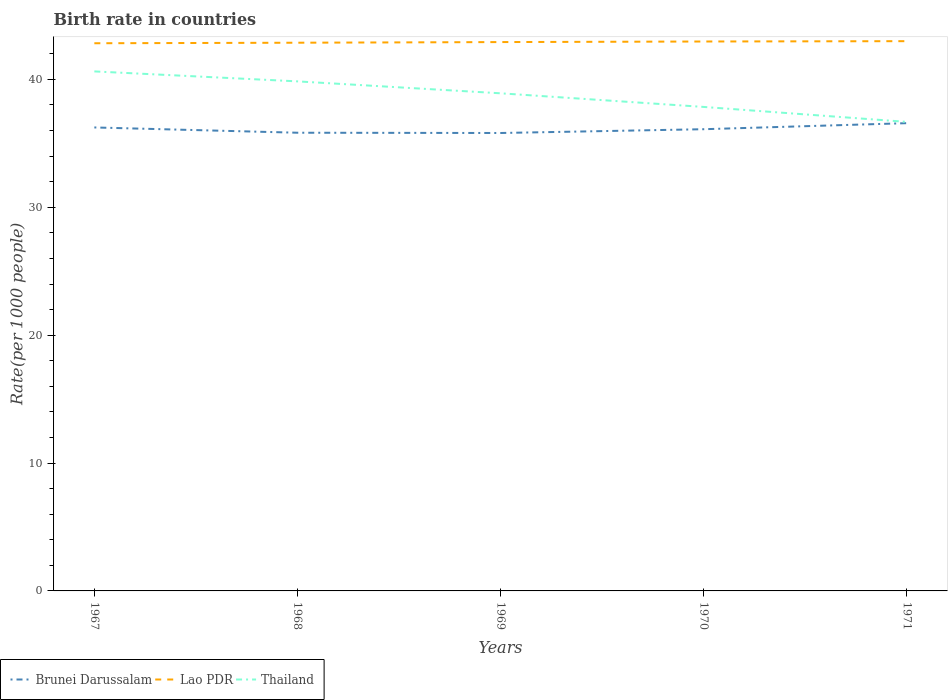Across all years, what is the maximum birth rate in Lao PDR?
Your response must be concise. 42.83. What is the total birth rate in Lao PDR in the graph?
Provide a short and direct response. -0.09. What is the difference between the highest and the second highest birth rate in Lao PDR?
Provide a short and direct response. 0.16. What is the difference between the highest and the lowest birth rate in Thailand?
Your answer should be compact. 3. Is the birth rate in Brunei Darussalam strictly greater than the birth rate in Lao PDR over the years?
Your answer should be very brief. Yes. How many lines are there?
Give a very brief answer. 3. How many years are there in the graph?
Keep it short and to the point. 5. Are the values on the major ticks of Y-axis written in scientific E-notation?
Keep it short and to the point. No. Does the graph contain any zero values?
Offer a terse response. No. Does the graph contain grids?
Give a very brief answer. No. How are the legend labels stacked?
Provide a short and direct response. Horizontal. What is the title of the graph?
Offer a very short reply. Birth rate in countries. Does "Korea (Republic)" appear as one of the legend labels in the graph?
Offer a very short reply. No. What is the label or title of the X-axis?
Provide a short and direct response. Years. What is the label or title of the Y-axis?
Your response must be concise. Rate(per 1000 people). What is the Rate(per 1000 people) of Brunei Darussalam in 1967?
Offer a very short reply. 36.24. What is the Rate(per 1000 people) in Lao PDR in 1967?
Offer a terse response. 42.83. What is the Rate(per 1000 people) in Thailand in 1967?
Offer a very short reply. 40.62. What is the Rate(per 1000 people) in Brunei Darussalam in 1968?
Offer a very short reply. 35.83. What is the Rate(per 1000 people) in Lao PDR in 1968?
Offer a terse response. 42.87. What is the Rate(per 1000 people) in Thailand in 1968?
Keep it short and to the point. 39.85. What is the Rate(per 1000 people) in Brunei Darussalam in 1969?
Provide a short and direct response. 35.81. What is the Rate(per 1000 people) of Lao PDR in 1969?
Your answer should be very brief. 42.92. What is the Rate(per 1000 people) of Thailand in 1969?
Provide a succinct answer. 38.91. What is the Rate(per 1000 people) of Brunei Darussalam in 1970?
Your response must be concise. 36.1. What is the Rate(per 1000 people) in Lao PDR in 1970?
Your answer should be compact. 42.96. What is the Rate(per 1000 people) of Thailand in 1970?
Your answer should be compact. 37.85. What is the Rate(per 1000 people) of Brunei Darussalam in 1971?
Ensure brevity in your answer.  36.58. What is the Rate(per 1000 people) in Lao PDR in 1971?
Offer a very short reply. 42.99. What is the Rate(per 1000 people) in Thailand in 1971?
Make the answer very short. 36.68. Across all years, what is the maximum Rate(per 1000 people) of Brunei Darussalam?
Keep it short and to the point. 36.58. Across all years, what is the maximum Rate(per 1000 people) in Lao PDR?
Ensure brevity in your answer.  42.99. Across all years, what is the maximum Rate(per 1000 people) of Thailand?
Keep it short and to the point. 40.62. Across all years, what is the minimum Rate(per 1000 people) in Brunei Darussalam?
Your response must be concise. 35.81. Across all years, what is the minimum Rate(per 1000 people) in Lao PDR?
Your answer should be compact. 42.83. Across all years, what is the minimum Rate(per 1000 people) of Thailand?
Your answer should be very brief. 36.68. What is the total Rate(per 1000 people) in Brunei Darussalam in the graph?
Your response must be concise. 180.56. What is the total Rate(per 1000 people) in Lao PDR in the graph?
Your answer should be very brief. 214.57. What is the total Rate(per 1000 people) of Thailand in the graph?
Your answer should be compact. 193.91. What is the difference between the Rate(per 1000 people) in Brunei Darussalam in 1967 and that in 1968?
Offer a very short reply. 0.41. What is the difference between the Rate(per 1000 people) in Lao PDR in 1967 and that in 1968?
Keep it short and to the point. -0.04. What is the difference between the Rate(per 1000 people) of Thailand in 1967 and that in 1968?
Your answer should be very brief. 0.78. What is the difference between the Rate(per 1000 people) of Brunei Darussalam in 1967 and that in 1969?
Provide a short and direct response. 0.43. What is the difference between the Rate(per 1000 people) in Lao PDR in 1967 and that in 1969?
Your answer should be very brief. -0.09. What is the difference between the Rate(per 1000 people) of Thailand in 1967 and that in 1969?
Give a very brief answer. 1.71. What is the difference between the Rate(per 1000 people) in Brunei Darussalam in 1967 and that in 1970?
Provide a succinct answer. 0.14. What is the difference between the Rate(per 1000 people) of Lao PDR in 1967 and that in 1970?
Your answer should be very brief. -0.14. What is the difference between the Rate(per 1000 people) in Thailand in 1967 and that in 1970?
Your response must be concise. 2.78. What is the difference between the Rate(per 1000 people) of Brunei Darussalam in 1967 and that in 1971?
Your response must be concise. -0.34. What is the difference between the Rate(per 1000 people) of Lao PDR in 1967 and that in 1971?
Your answer should be very brief. -0.16. What is the difference between the Rate(per 1000 people) in Thailand in 1967 and that in 1971?
Provide a short and direct response. 3.95. What is the difference between the Rate(per 1000 people) in Brunei Darussalam in 1968 and that in 1969?
Make the answer very short. 0.02. What is the difference between the Rate(per 1000 people) in Lao PDR in 1968 and that in 1969?
Make the answer very short. -0.05. What is the difference between the Rate(per 1000 people) in Thailand in 1968 and that in 1969?
Provide a short and direct response. 0.93. What is the difference between the Rate(per 1000 people) in Brunei Darussalam in 1968 and that in 1970?
Ensure brevity in your answer.  -0.28. What is the difference between the Rate(per 1000 people) in Lao PDR in 1968 and that in 1970?
Your response must be concise. -0.1. What is the difference between the Rate(per 1000 people) in Thailand in 1968 and that in 1970?
Offer a terse response. 2. What is the difference between the Rate(per 1000 people) of Brunei Darussalam in 1968 and that in 1971?
Ensure brevity in your answer.  -0.75. What is the difference between the Rate(per 1000 people) in Lao PDR in 1968 and that in 1971?
Provide a succinct answer. -0.12. What is the difference between the Rate(per 1000 people) in Thailand in 1968 and that in 1971?
Provide a succinct answer. 3.17. What is the difference between the Rate(per 1000 people) in Brunei Darussalam in 1969 and that in 1970?
Keep it short and to the point. -0.3. What is the difference between the Rate(per 1000 people) of Lao PDR in 1969 and that in 1970?
Offer a very short reply. -0.04. What is the difference between the Rate(per 1000 people) in Thailand in 1969 and that in 1970?
Provide a short and direct response. 1.07. What is the difference between the Rate(per 1000 people) in Brunei Darussalam in 1969 and that in 1971?
Your response must be concise. -0.77. What is the difference between the Rate(per 1000 people) in Lao PDR in 1969 and that in 1971?
Ensure brevity in your answer.  -0.07. What is the difference between the Rate(per 1000 people) in Thailand in 1969 and that in 1971?
Offer a terse response. 2.24. What is the difference between the Rate(per 1000 people) in Brunei Darussalam in 1970 and that in 1971?
Your response must be concise. -0.47. What is the difference between the Rate(per 1000 people) in Lao PDR in 1970 and that in 1971?
Your answer should be very brief. -0.03. What is the difference between the Rate(per 1000 people) in Thailand in 1970 and that in 1971?
Your response must be concise. 1.17. What is the difference between the Rate(per 1000 people) of Brunei Darussalam in 1967 and the Rate(per 1000 people) of Lao PDR in 1968?
Your response must be concise. -6.63. What is the difference between the Rate(per 1000 people) of Brunei Darussalam in 1967 and the Rate(per 1000 people) of Thailand in 1968?
Your response must be concise. -3.6. What is the difference between the Rate(per 1000 people) of Lao PDR in 1967 and the Rate(per 1000 people) of Thailand in 1968?
Make the answer very short. 2.98. What is the difference between the Rate(per 1000 people) in Brunei Darussalam in 1967 and the Rate(per 1000 people) in Lao PDR in 1969?
Provide a short and direct response. -6.68. What is the difference between the Rate(per 1000 people) of Brunei Darussalam in 1967 and the Rate(per 1000 people) of Thailand in 1969?
Your response must be concise. -2.67. What is the difference between the Rate(per 1000 people) of Lao PDR in 1967 and the Rate(per 1000 people) of Thailand in 1969?
Ensure brevity in your answer.  3.91. What is the difference between the Rate(per 1000 people) in Brunei Darussalam in 1967 and the Rate(per 1000 people) in Lao PDR in 1970?
Your answer should be compact. -6.72. What is the difference between the Rate(per 1000 people) of Brunei Darussalam in 1967 and the Rate(per 1000 people) of Thailand in 1970?
Provide a succinct answer. -1.6. What is the difference between the Rate(per 1000 people) of Lao PDR in 1967 and the Rate(per 1000 people) of Thailand in 1970?
Give a very brief answer. 4.98. What is the difference between the Rate(per 1000 people) of Brunei Darussalam in 1967 and the Rate(per 1000 people) of Lao PDR in 1971?
Your answer should be very brief. -6.75. What is the difference between the Rate(per 1000 people) in Brunei Darussalam in 1967 and the Rate(per 1000 people) in Thailand in 1971?
Provide a succinct answer. -0.43. What is the difference between the Rate(per 1000 people) in Lao PDR in 1967 and the Rate(per 1000 people) in Thailand in 1971?
Your answer should be compact. 6.15. What is the difference between the Rate(per 1000 people) in Brunei Darussalam in 1968 and the Rate(per 1000 people) in Lao PDR in 1969?
Provide a short and direct response. -7.09. What is the difference between the Rate(per 1000 people) in Brunei Darussalam in 1968 and the Rate(per 1000 people) in Thailand in 1969?
Your answer should be very brief. -3.08. What is the difference between the Rate(per 1000 people) in Lao PDR in 1968 and the Rate(per 1000 people) in Thailand in 1969?
Make the answer very short. 3.96. What is the difference between the Rate(per 1000 people) of Brunei Darussalam in 1968 and the Rate(per 1000 people) of Lao PDR in 1970?
Offer a very short reply. -7.13. What is the difference between the Rate(per 1000 people) in Brunei Darussalam in 1968 and the Rate(per 1000 people) in Thailand in 1970?
Your answer should be very brief. -2.02. What is the difference between the Rate(per 1000 people) in Lao PDR in 1968 and the Rate(per 1000 people) in Thailand in 1970?
Ensure brevity in your answer.  5.02. What is the difference between the Rate(per 1000 people) of Brunei Darussalam in 1968 and the Rate(per 1000 people) of Lao PDR in 1971?
Provide a succinct answer. -7.16. What is the difference between the Rate(per 1000 people) in Brunei Darussalam in 1968 and the Rate(per 1000 people) in Thailand in 1971?
Your answer should be very brief. -0.85. What is the difference between the Rate(per 1000 people) in Lao PDR in 1968 and the Rate(per 1000 people) in Thailand in 1971?
Provide a short and direct response. 6.19. What is the difference between the Rate(per 1000 people) in Brunei Darussalam in 1969 and the Rate(per 1000 people) in Lao PDR in 1970?
Make the answer very short. -7.16. What is the difference between the Rate(per 1000 people) of Brunei Darussalam in 1969 and the Rate(per 1000 people) of Thailand in 1970?
Provide a succinct answer. -2.04. What is the difference between the Rate(per 1000 people) in Lao PDR in 1969 and the Rate(per 1000 people) in Thailand in 1970?
Give a very brief answer. 5.07. What is the difference between the Rate(per 1000 people) of Brunei Darussalam in 1969 and the Rate(per 1000 people) of Lao PDR in 1971?
Ensure brevity in your answer.  -7.18. What is the difference between the Rate(per 1000 people) in Brunei Darussalam in 1969 and the Rate(per 1000 people) in Thailand in 1971?
Ensure brevity in your answer.  -0.87. What is the difference between the Rate(per 1000 people) of Lao PDR in 1969 and the Rate(per 1000 people) of Thailand in 1971?
Ensure brevity in your answer.  6.24. What is the difference between the Rate(per 1000 people) of Brunei Darussalam in 1970 and the Rate(per 1000 people) of Lao PDR in 1971?
Your answer should be compact. -6.88. What is the difference between the Rate(per 1000 people) of Brunei Darussalam in 1970 and the Rate(per 1000 people) of Thailand in 1971?
Your answer should be very brief. -0.57. What is the difference between the Rate(per 1000 people) in Lao PDR in 1970 and the Rate(per 1000 people) in Thailand in 1971?
Provide a short and direct response. 6.29. What is the average Rate(per 1000 people) in Brunei Darussalam per year?
Offer a very short reply. 36.11. What is the average Rate(per 1000 people) of Lao PDR per year?
Offer a terse response. 42.91. What is the average Rate(per 1000 people) of Thailand per year?
Provide a short and direct response. 38.78. In the year 1967, what is the difference between the Rate(per 1000 people) in Brunei Darussalam and Rate(per 1000 people) in Lao PDR?
Ensure brevity in your answer.  -6.58. In the year 1967, what is the difference between the Rate(per 1000 people) of Brunei Darussalam and Rate(per 1000 people) of Thailand?
Provide a short and direct response. -4.38. In the year 1967, what is the difference between the Rate(per 1000 people) of Lao PDR and Rate(per 1000 people) of Thailand?
Keep it short and to the point. 2.2. In the year 1968, what is the difference between the Rate(per 1000 people) of Brunei Darussalam and Rate(per 1000 people) of Lao PDR?
Your answer should be very brief. -7.04. In the year 1968, what is the difference between the Rate(per 1000 people) in Brunei Darussalam and Rate(per 1000 people) in Thailand?
Provide a short and direct response. -4.02. In the year 1968, what is the difference between the Rate(per 1000 people) of Lao PDR and Rate(per 1000 people) of Thailand?
Your response must be concise. 3.02. In the year 1969, what is the difference between the Rate(per 1000 people) of Brunei Darussalam and Rate(per 1000 people) of Lao PDR?
Give a very brief answer. -7.11. In the year 1969, what is the difference between the Rate(per 1000 people) in Brunei Darussalam and Rate(per 1000 people) in Thailand?
Make the answer very short. -3.1. In the year 1969, what is the difference between the Rate(per 1000 people) in Lao PDR and Rate(per 1000 people) in Thailand?
Give a very brief answer. 4.01. In the year 1970, what is the difference between the Rate(per 1000 people) of Brunei Darussalam and Rate(per 1000 people) of Lao PDR?
Provide a short and direct response. -6.86. In the year 1970, what is the difference between the Rate(per 1000 people) in Brunei Darussalam and Rate(per 1000 people) in Thailand?
Offer a terse response. -1.74. In the year 1970, what is the difference between the Rate(per 1000 people) of Lao PDR and Rate(per 1000 people) of Thailand?
Make the answer very short. 5.12. In the year 1971, what is the difference between the Rate(per 1000 people) of Brunei Darussalam and Rate(per 1000 people) of Lao PDR?
Ensure brevity in your answer.  -6.41. In the year 1971, what is the difference between the Rate(per 1000 people) of Brunei Darussalam and Rate(per 1000 people) of Thailand?
Your answer should be very brief. -0.1. In the year 1971, what is the difference between the Rate(per 1000 people) of Lao PDR and Rate(per 1000 people) of Thailand?
Keep it short and to the point. 6.31. What is the ratio of the Rate(per 1000 people) of Brunei Darussalam in 1967 to that in 1968?
Provide a short and direct response. 1.01. What is the ratio of the Rate(per 1000 people) in Lao PDR in 1967 to that in 1968?
Make the answer very short. 1. What is the ratio of the Rate(per 1000 people) in Thailand in 1967 to that in 1968?
Make the answer very short. 1.02. What is the ratio of the Rate(per 1000 people) in Brunei Darussalam in 1967 to that in 1969?
Keep it short and to the point. 1.01. What is the ratio of the Rate(per 1000 people) of Lao PDR in 1967 to that in 1969?
Ensure brevity in your answer.  1. What is the ratio of the Rate(per 1000 people) of Thailand in 1967 to that in 1969?
Offer a very short reply. 1.04. What is the ratio of the Rate(per 1000 people) of Brunei Darussalam in 1967 to that in 1970?
Make the answer very short. 1. What is the ratio of the Rate(per 1000 people) of Lao PDR in 1967 to that in 1970?
Offer a very short reply. 1. What is the ratio of the Rate(per 1000 people) in Thailand in 1967 to that in 1970?
Give a very brief answer. 1.07. What is the ratio of the Rate(per 1000 people) of Thailand in 1967 to that in 1971?
Your answer should be very brief. 1.11. What is the ratio of the Rate(per 1000 people) of Brunei Darussalam in 1968 to that in 1969?
Your response must be concise. 1. What is the ratio of the Rate(per 1000 people) in Lao PDR in 1968 to that in 1969?
Offer a very short reply. 1. What is the ratio of the Rate(per 1000 people) of Lao PDR in 1968 to that in 1970?
Your response must be concise. 1. What is the ratio of the Rate(per 1000 people) in Thailand in 1968 to that in 1970?
Offer a very short reply. 1.05. What is the ratio of the Rate(per 1000 people) of Brunei Darussalam in 1968 to that in 1971?
Your response must be concise. 0.98. What is the ratio of the Rate(per 1000 people) in Thailand in 1968 to that in 1971?
Your answer should be compact. 1.09. What is the ratio of the Rate(per 1000 people) of Brunei Darussalam in 1969 to that in 1970?
Ensure brevity in your answer.  0.99. What is the ratio of the Rate(per 1000 people) in Thailand in 1969 to that in 1970?
Offer a very short reply. 1.03. What is the ratio of the Rate(per 1000 people) of Lao PDR in 1969 to that in 1971?
Offer a terse response. 1. What is the ratio of the Rate(per 1000 people) of Thailand in 1969 to that in 1971?
Your answer should be very brief. 1.06. What is the ratio of the Rate(per 1000 people) in Brunei Darussalam in 1970 to that in 1971?
Your response must be concise. 0.99. What is the ratio of the Rate(per 1000 people) in Lao PDR in 1970 to that in 1971?
Your response must be concise. 1. What is the ratio of the Rate(per 1000 people) of Thailand in 1970 to that in 1971?
Keep it short and to the point. 1.03. What is the difference between the highest and the second highest Rate(per 1000 people) in Brunei Darussalam?
Ensure brevity in your answer.  0.34. What is the difference between the highest and the second highest Rate(per 1000 people) of Lao PDR?
Give a very brief answer. 0.03. What is the difference between the highest and the second highest Rate(per 1000 people) of Thailand?
Your response must be concise. 0.78. What is the difference between the highest and the lowest Rate(per 1000 people) of Brunei Darussalam?
Give a very brief answer. 0.77. What is the difference between the highest and the lowest Rate(per 1000 people) in Lao PDR?
Offer a very short reply. 0.16. What is the difference between the highest and the lowest Rate(per 1000 people) in Thailand?
Make the answer very short. 3.95. 